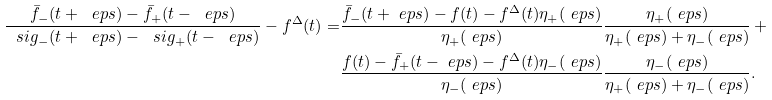Convert formula to latex. <formula><loc_0><loc_0><loc_500><loc_500>\frac { \bar { f } _ { - } ( t + \ e p s ) - \bar { f } _ { + } ( t - \ e p s ) } { \ s i g _ { - } ( t + \ e p s ) - \ s i g _ { + } ( t - \ e p s ) } - f ^ { \Delta } ( t ) = & \frac { \bar { f } _ { - } ( t + \ e p s ) - f ( t ) - f ^ { \Delta } ( t ) \eta _ { + } ( \ e p s ) } { \eta _ { + } ( \ e p s ) } \frac { \eta _ { + } ( \ e p s ) } { \eta _ { + } ( \ e p s ) + \eta _ { - } ( \ e p s ) } \, + \\ & \frac { f ( t ) - \bar { f } _ { + } ( t - \ e p s ) - f ^ { \Delta } ( t ) \eta _ { - } ( \ e p s ) } { \eta _ { - } ( \ e p s ) } \frac { \eta _ { - } ( \ e p s ) } { \eta _ { + } ( \ e p s ) + \eta _ { - } ( \ e p s ) } .</formula> 